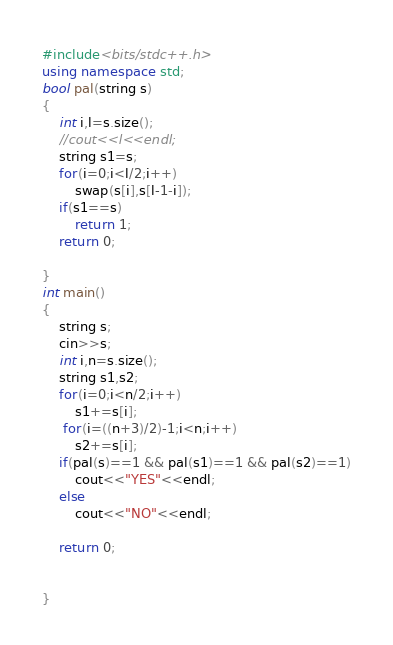Convert code to text. <code><loc_0><loc_0><loc_500><loc_500><_C++_>#include<bits/stdc++.h>
using namespace std;
bool pal(string s)
{
    int i,l=s.size();
    //cout<<l<<endl;
    string s1=s;
    for(i=0;i<l/2;i++)
        swap(s[i],s[l-1-i]);
    if(s1==s)
        return 1;
    return 0;

}
int main()
{
    string s;
    cin>>s;
    int i,n=s.size();
    string s1,s2;
    for(i=0;i<n/2;i++)
        s1+=s[i];
     for(i=((n+3)/2)-1;i<n;i++)
        s2+=s[i];
    if(pal(s)==1 && pal(s1)==1 && pal(s2)==1)
        cout<<"YES"<<endl;
    else
        cout<<"NO"<<endl;

    return 0;


}
</code> 